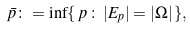<formula> <loc_0><loc_0><loc_500><loc_500>\bar { p } \colon = \inf \{ \, p \, \colon \, | E _ { p } | = | \Omega | \, \} ,</formula> 